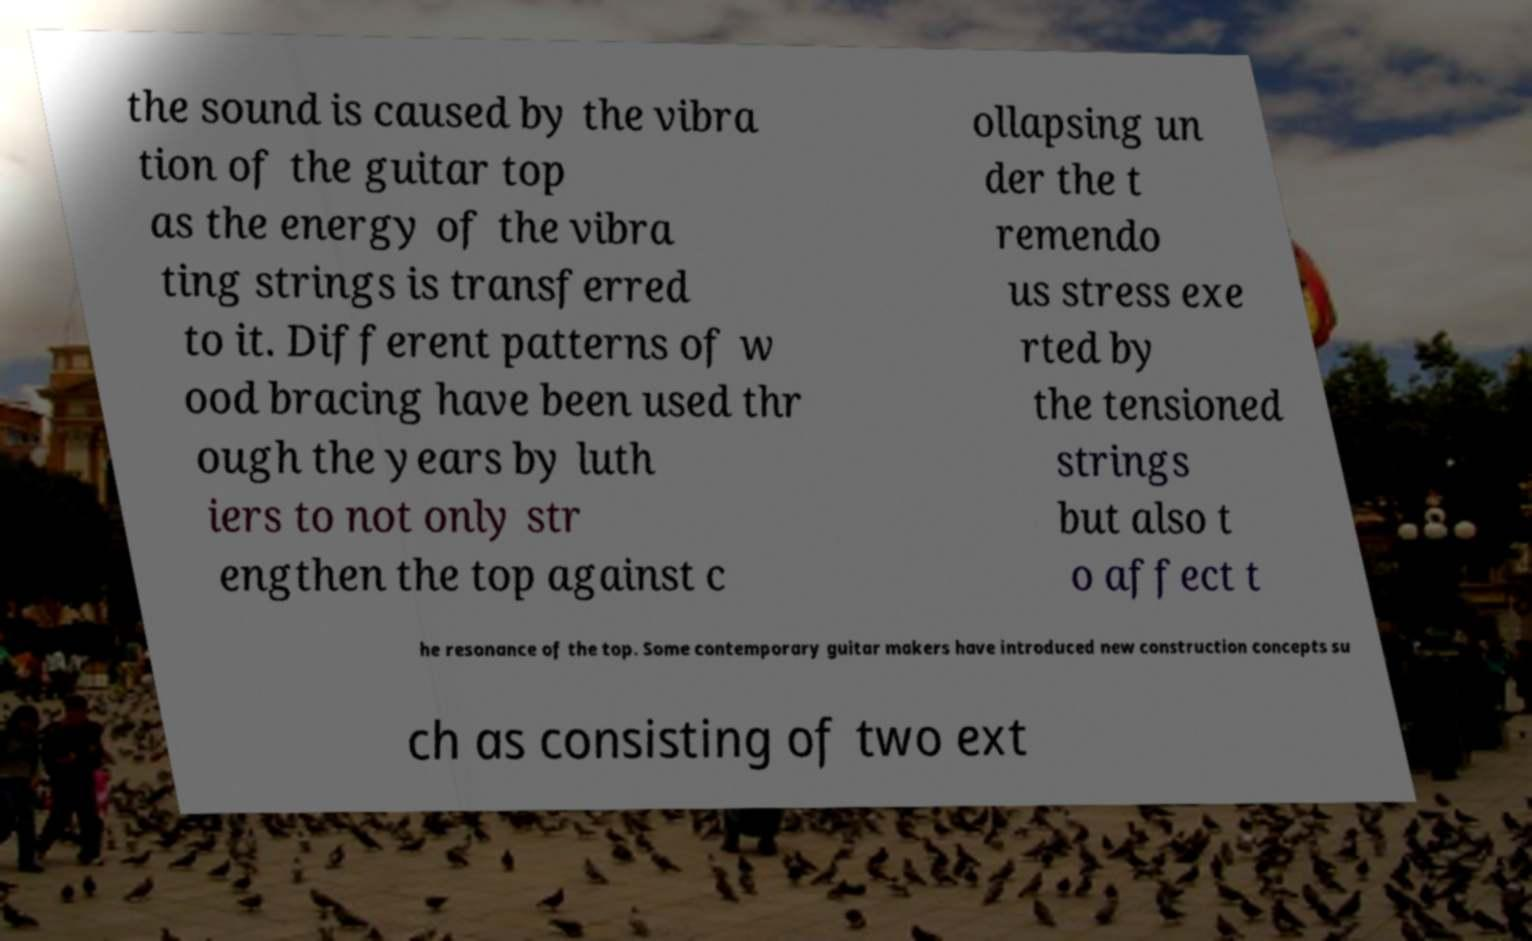What messages or text are displayed in this image? I need them in a readable, typed format. the sound is caused by the vibra tion of the guitar top as the energy of the vibra ting strings is transferred to it. Different patterns of w ood bracing have been used thr ough the years by luth iers to not only str engthen the top against c ollapsing un der the t remendo us stress exe rted by the tensioned strings but also t o affect t he resonance of the top. Some contemporary guitar makers have introduced new construction concepts su ch as consisting of two ext 